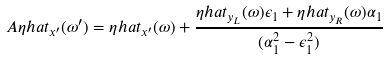<formula> <loc_0><loc_0><loc_500><loc_500>A \eta h a t _ { x ^ { \prime } } ( \omega ^ { \prime } ) = \eta h a t _ { x ^ { \prime } } ( \omega ) + \frac { \eta h a t _ { y _ { L } } ( \omega ) \epsilon _ { 1 } + \eta h a t _ { y _ { R } } ( \omega ) \alpha _ { 1 } } { ( \alpha _ { 1 } ^ { 2 } - \epsilon _ { 1 } ^ { 2 } ) }</formula> 